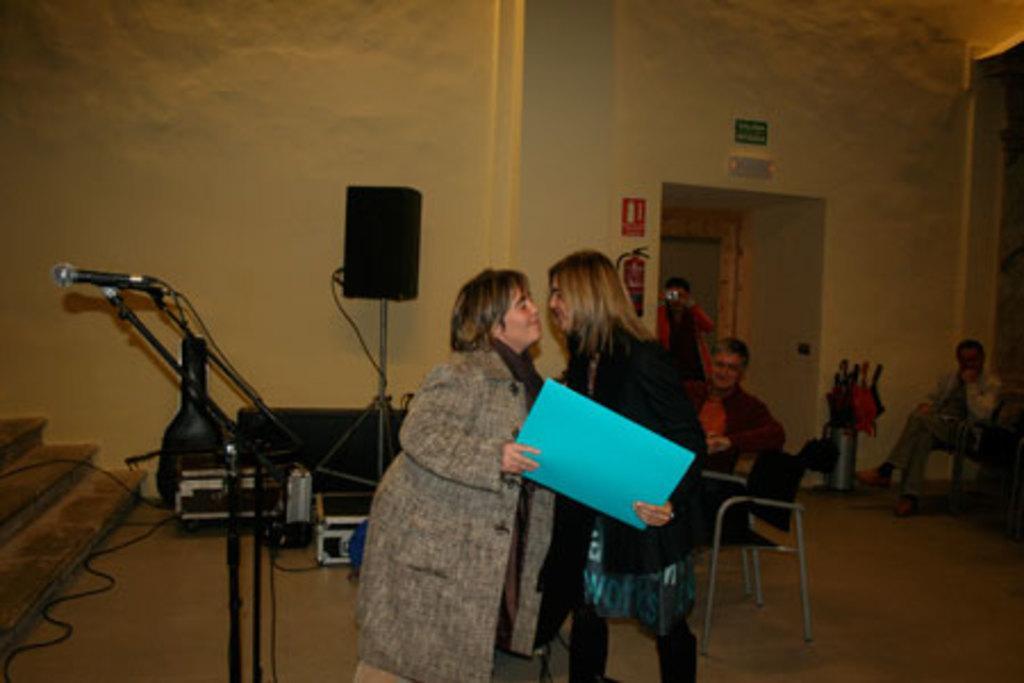In one or two sentences, can you explain what this image depicts? In this image I can see the group of people with different color dresses. I can see few people are sitting and few people are standing. I can see two people holding the blue color object. To the left I can see the mic, sound system, wires and some objects. In the background I can see the fire extinguisher and some boards to the wall. 